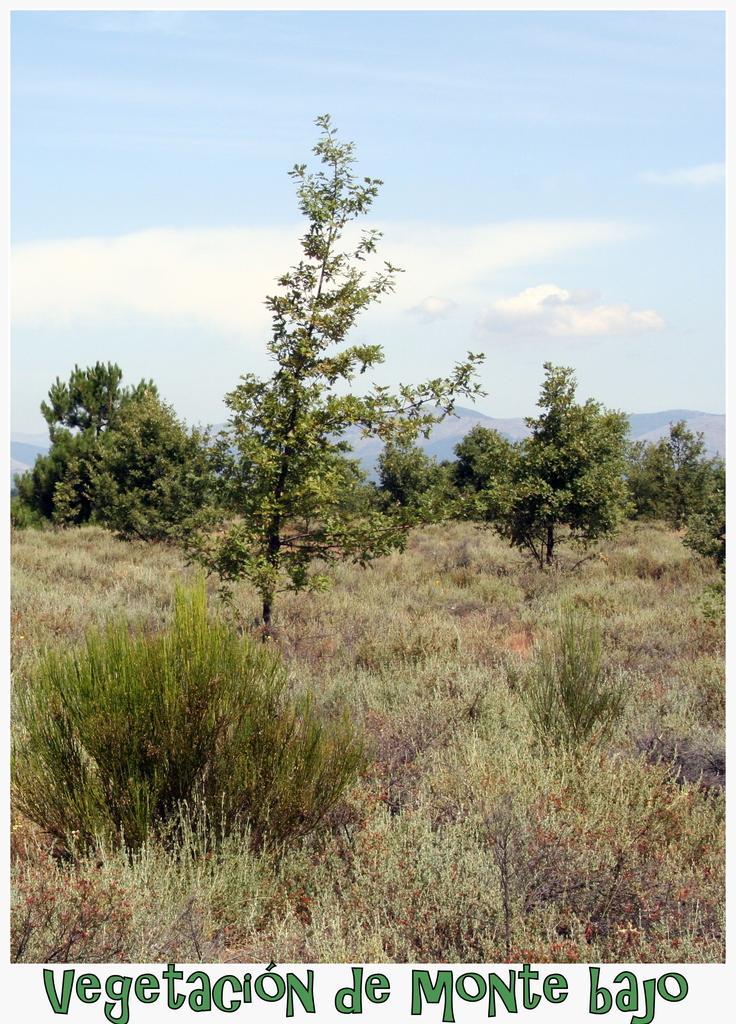How would you summarize this image in a sentence or two? This looks like an edited image. I can see the plants and bushes. These are the trees. In the background, these look like the hills. I can see the clouds in the sky. At the bottom of the image, I can see the watermark. 